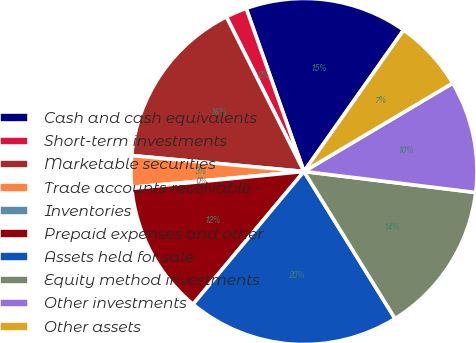Convert chart to OTSL. <chart><loc_0><loc_0><loc_500><loc_500><pie_chart><fcel>Cash and cash equivalents<fcel>Short-term investments<fcel>Marketable securities<fcel>Trade accounts receivable -<fcel>Inventories<fcel>Prepaid expenses and other<fcel>Assets held for sale<fcel>Equity method investments<fcel>Other investments<fcel>Other assets<nl><fcel>15.19%<fcel>1.98%<fcel>16.13%<fcel>2.93%<fcel>0.1%<fcel>12.36%<fcel>19.9%<fcel>14.24%<fcel>10.47%<fcel>6.7%<nl></chart> 